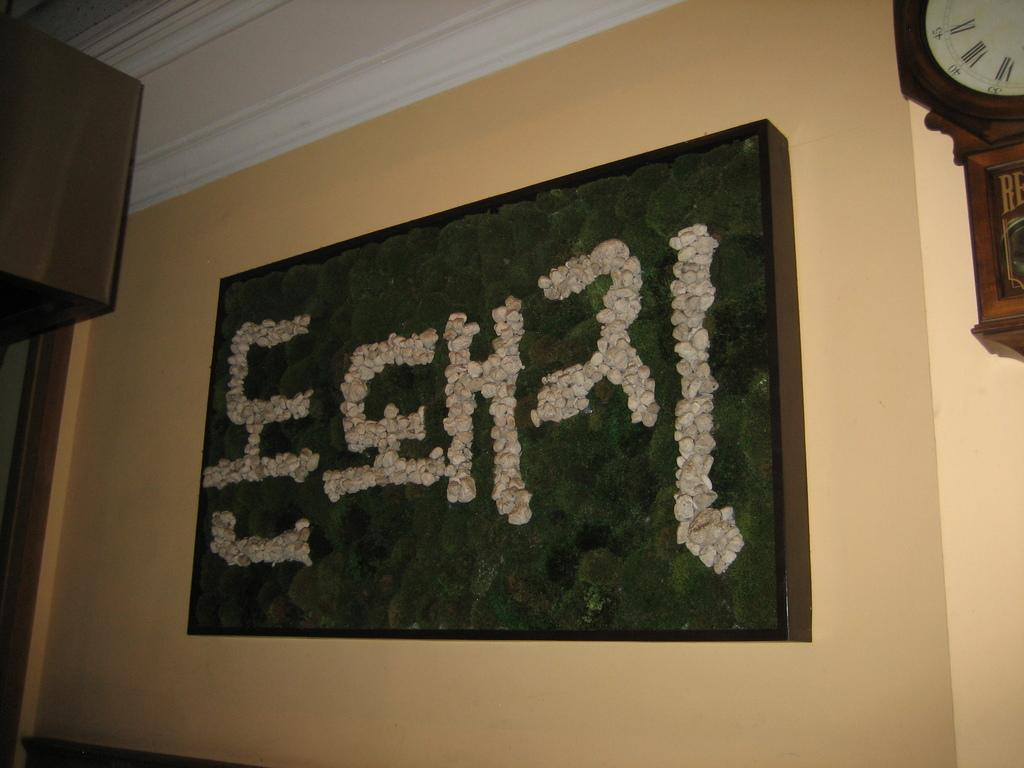What is present on the wall in the image? There is a board on the wall. What can be found on the board? There is text on the board. Where is the clock located in the image? The clock is in the top right corner of the image. How hot is the building in the image? There is no building present in the image, so it is not possible to determine its temperature. 